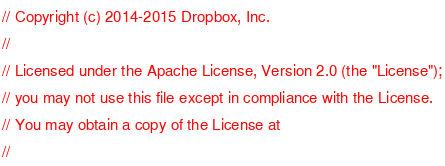Convert code to text. <code><loc_0><loc_0><loc_500><loc_500><_C++_>// Copyright (c) 2014-2015 Dropbox, Inc.
//
// Licensed under the Apache License, Version 2.0 (the "License");
// you may not use this file except in compliance with the License.
// You may obtain a copy of the License at
//</code> 